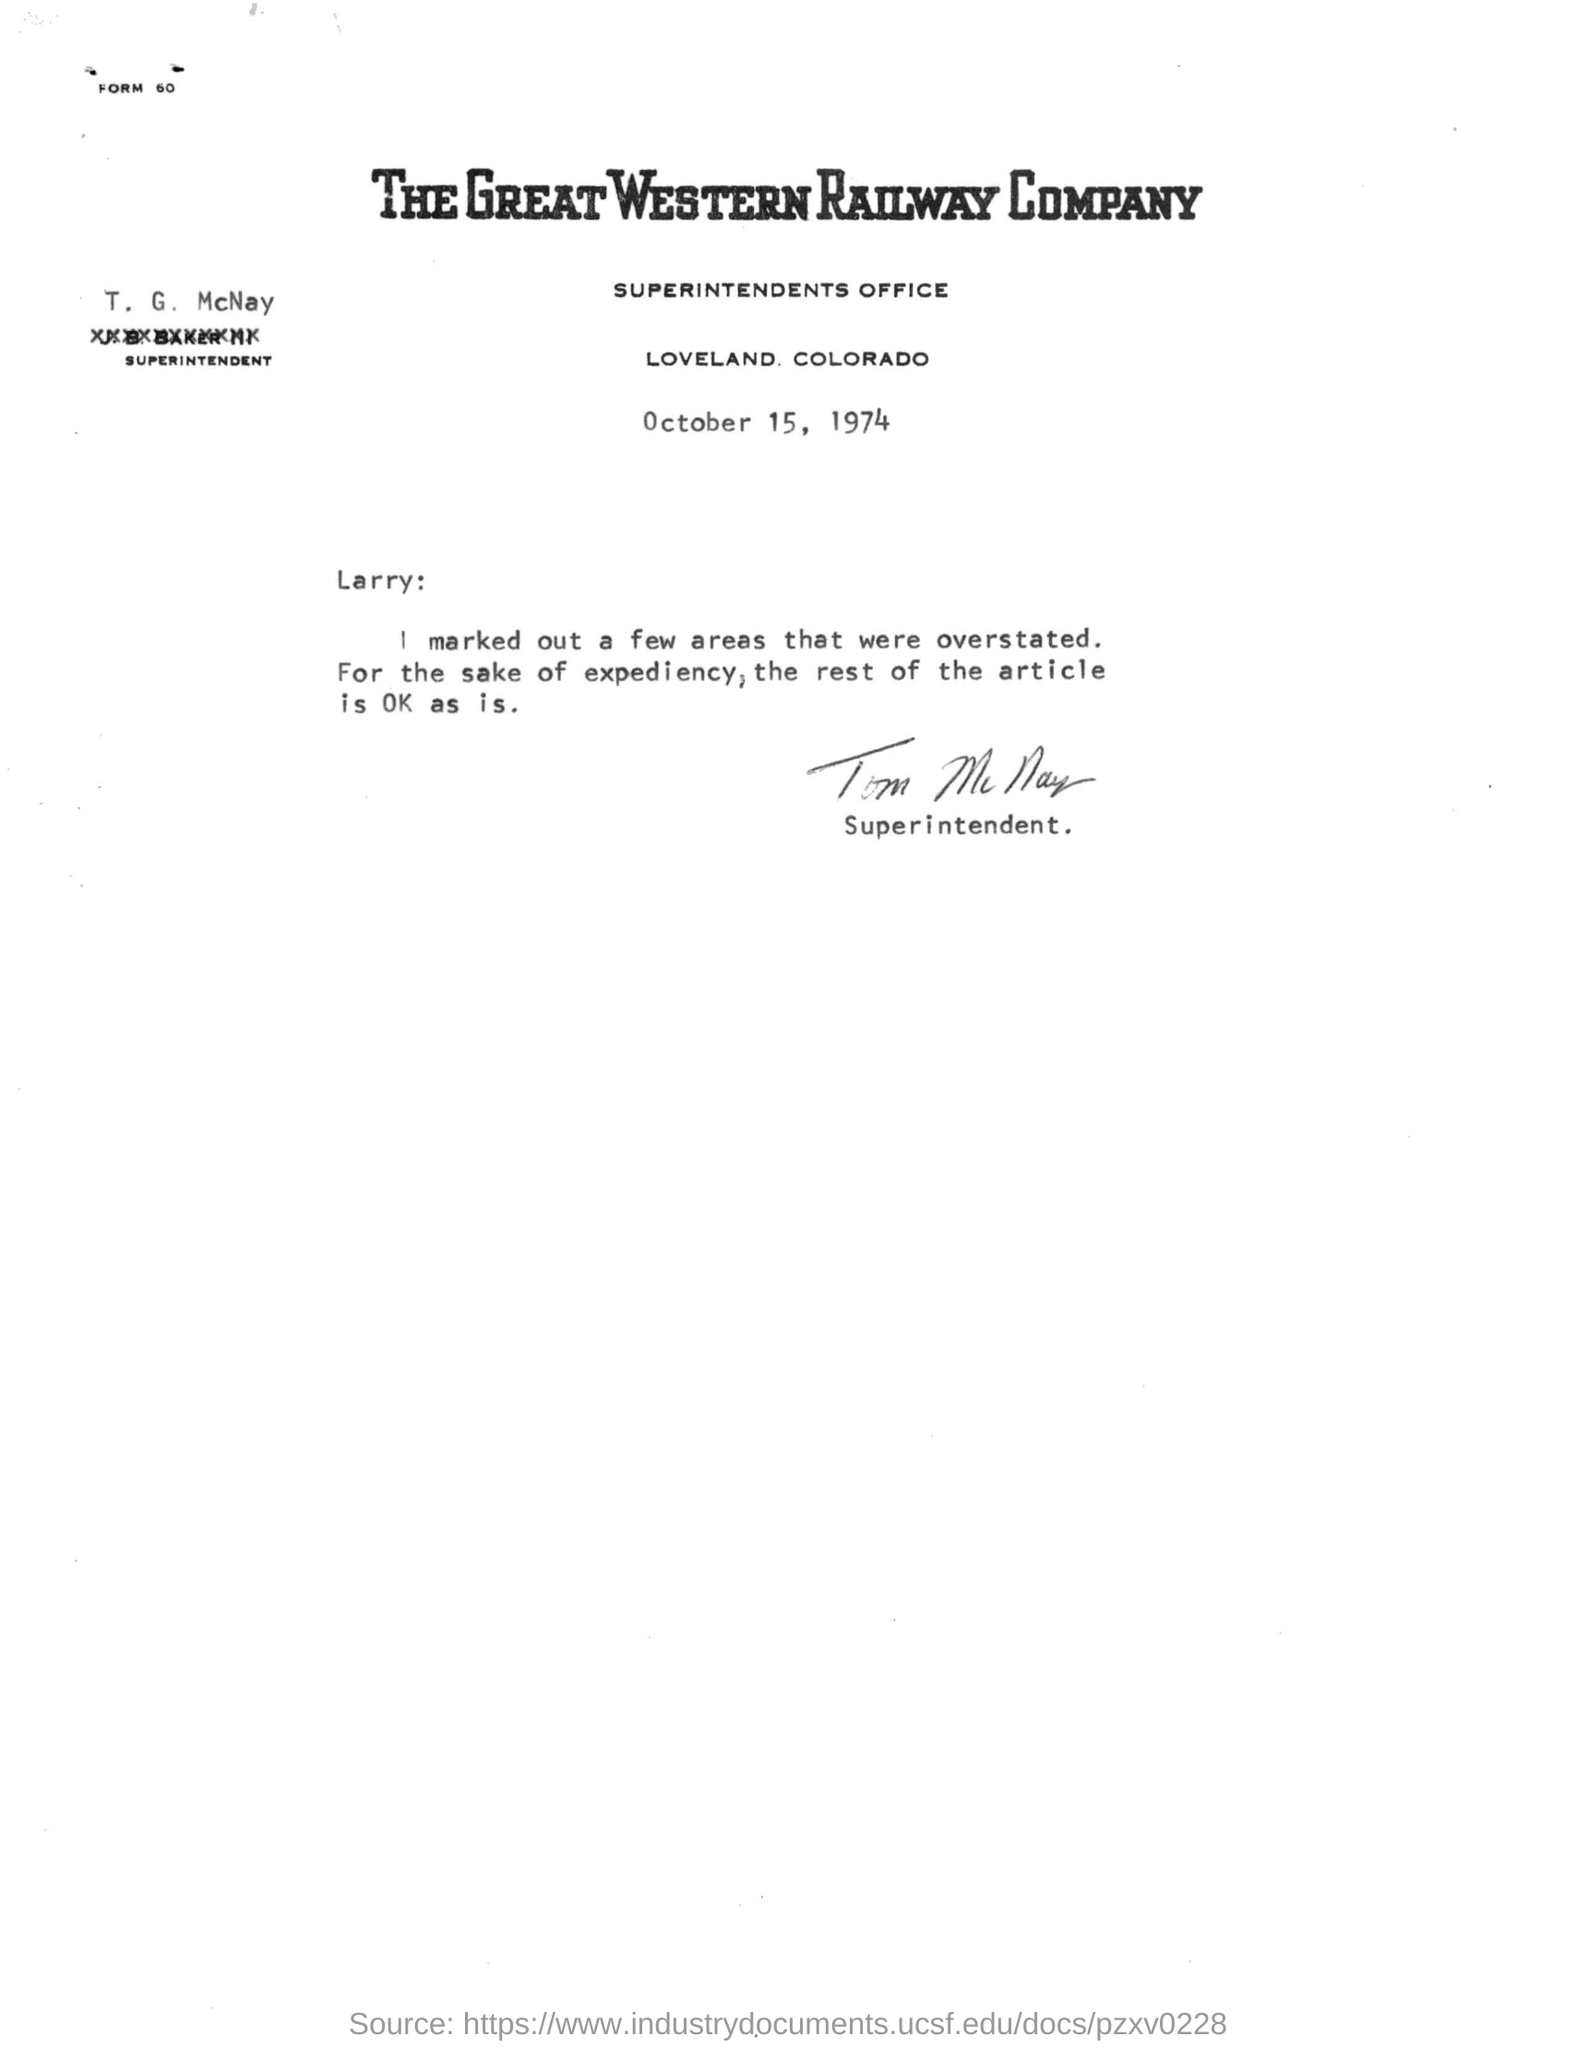Draw attention to some important aspects in this diagram. The letter is addressed to Larry. The superintendent's name is T.G McNay. The date of the letter is October 15, 1974. 